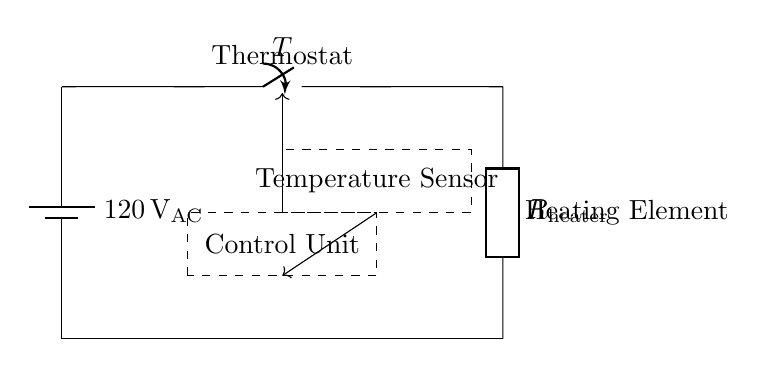What is the voltage of the power supply in this circuit? The circuit diagram indicates that the power supply is labeled as 120 volts AC. This is a standard value used in many electric heating appliances.
Answer: 120 volts AC What component acts as a switch in this circuit? A switch is labeled as T in the circuit diagram. It's shown in the path between the power supply and the heating element, controlling the flow of electricity.
Answer: Switch What is the purpose of the temperature sensor in this circuit? The temperature sensor is placed within a dashed rectangle, indicating its role in monitoring the temperature. It provides feedback to the control unit, which adjusts the heater operation based on the measured temperature.
Answer: Monitoring temperature What does the control unit do in relation to the thermostat? The control unit, indicated in the dashed rectangle, processes the information from the temperature sensor. It uses this data to decide whether to open or close the thermostat switch, thus controlling the heater operation.
Answer: Controls heater operation How many components are connected in series in this circuit? The circuit shows the power supply connected to the switch, which is in turn connected to the heating element. This forms a series connection as the current flows through one component to the next without branching.
Answer: Three components Is the heating element represented as a specific resistance value? In the circuit diagram, the heating element is labeled as R heater, indicating it is a resistive load without a specific numerical value provided. It signifies that it has resistance properties essential for converting electrical energy to heat.
Answer: No specific value 